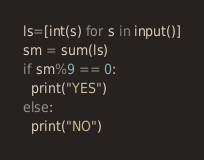<code> <loc_0><loc_0><loc_500><loc_500><_Python_>ls=[int(s) for s in input()]
sm = sum(ls)
if sm%9 == 0:
  print("YES")
else:
  print("NO")</code> 